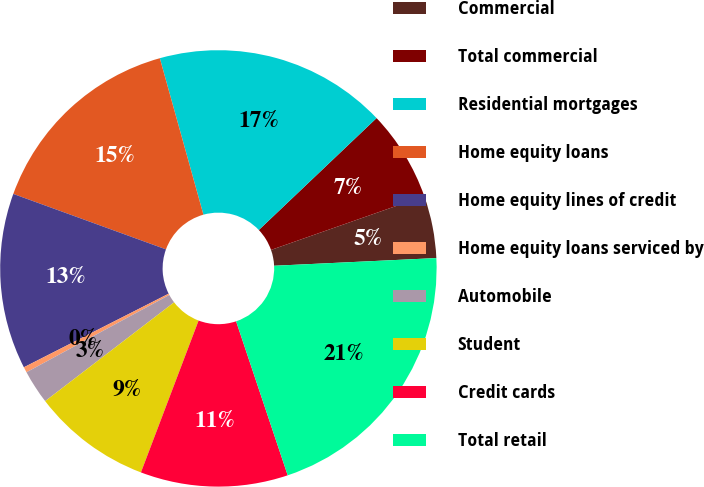Convert chart. <chart><loc_0><loc_0><loc_500><loc_500><pie_chart><fcel>Commercial<fcel>Total commercial<fcel>Residential mortgages<fcel>Home equity loans<fcel>Home equity lines of credit<fcel>Home equity loans serviced by<fcel>Automobile<fcel>Student<fcel>Credit cards<fcel>Total retail<nl><fcel>4.62%<fcel>6.72%<fcel>17.23%<fcel>15.13%<fcel>13.03%<fcel>0.41%<fcel>2.51%<fcel>8.82%<fcel>10.92%<fcel>20.61%<nl></chart> 